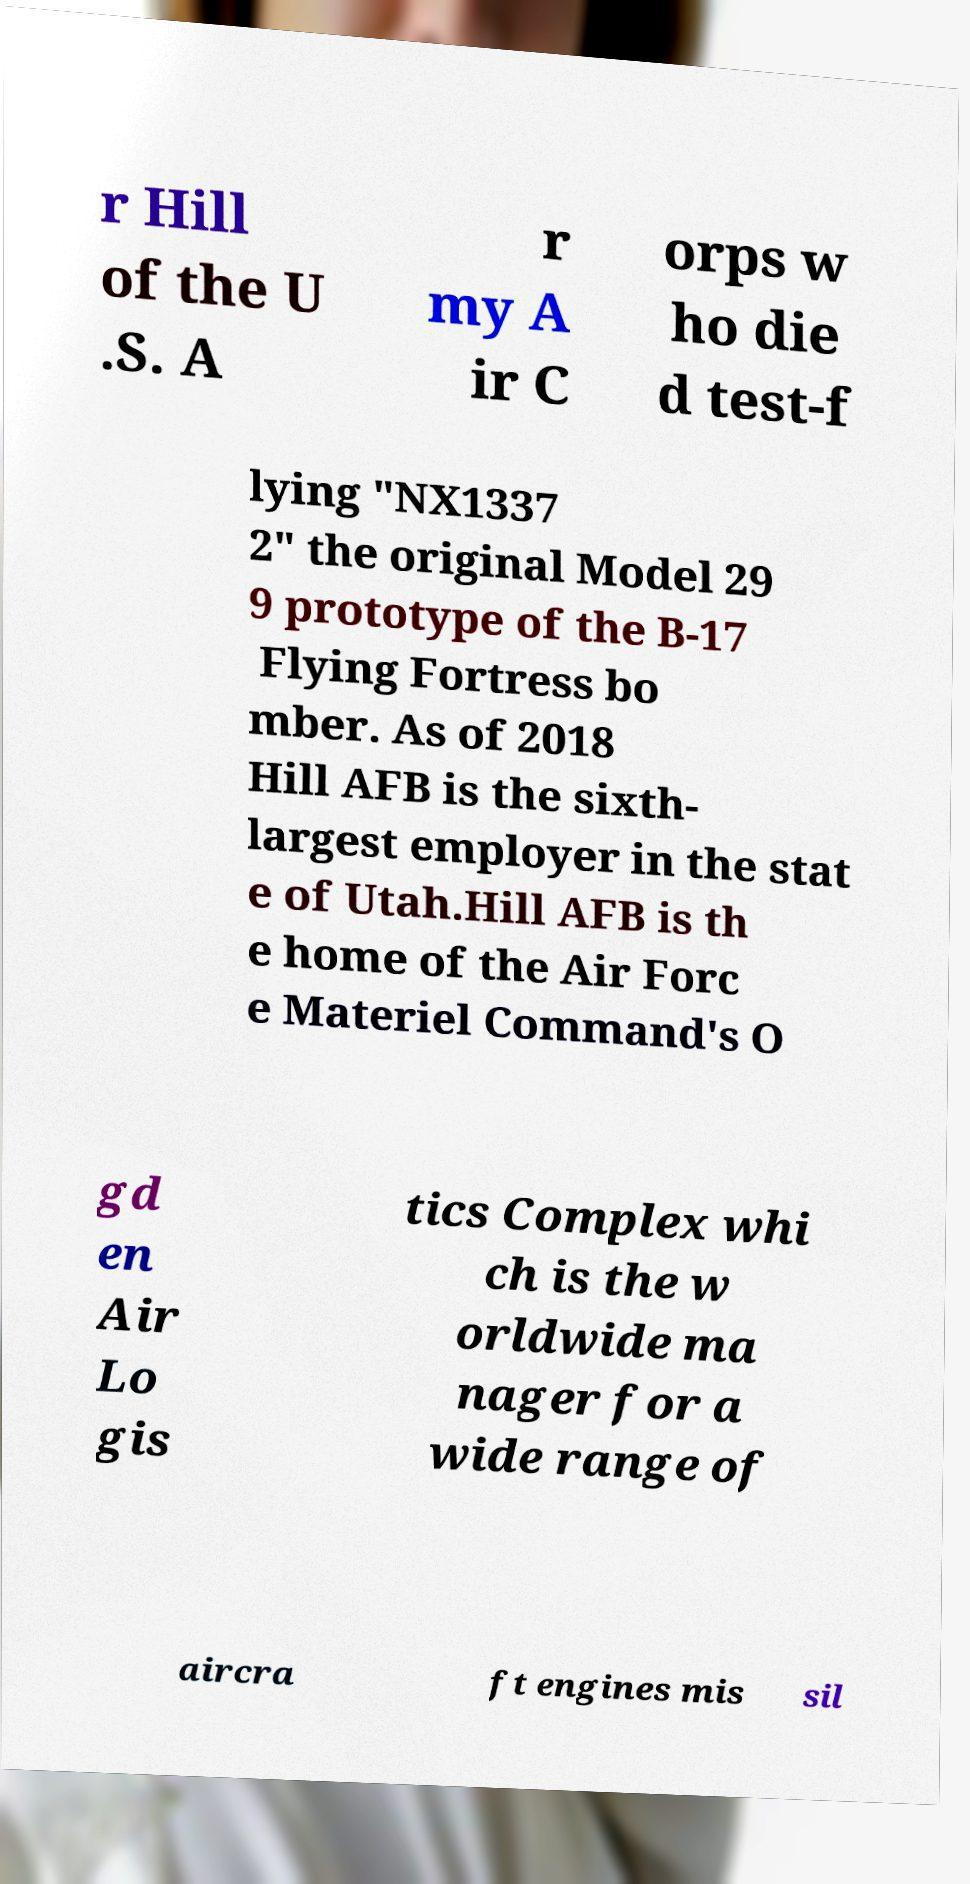For documentation purposes, I need the text within this image transcribed. Could you provide that? r Hill of the U .S. A r my A ir C orps w ho die d test-f lying "NX1337 2" the original Model 29 9 prototype of the B-17 Flying Fortress bo mber. As of 2018 Hill AFB is the sixth- largest employer in the stat e of Utah.Hill AFB is th e home of the Air Forc e Materiel Command's O gd en Air Lo gis tics Complex whi ch is the w orldwide ma nager for a wide range of aircra ft engines mis sil 